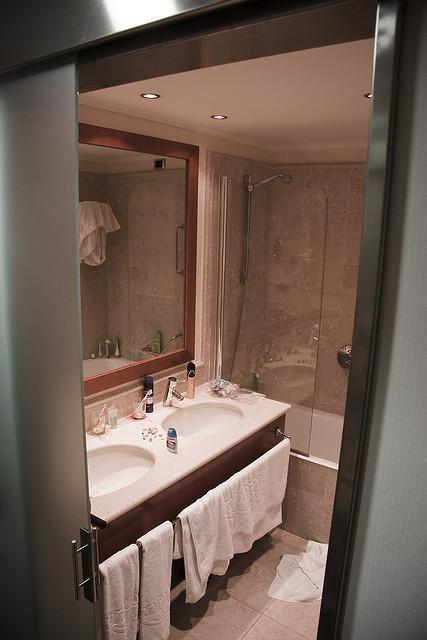How many sinks are in the picture?
Give a very brief answer. 2. How many towels are hanging on the towel rack?
Give a very brief answer. 3. 